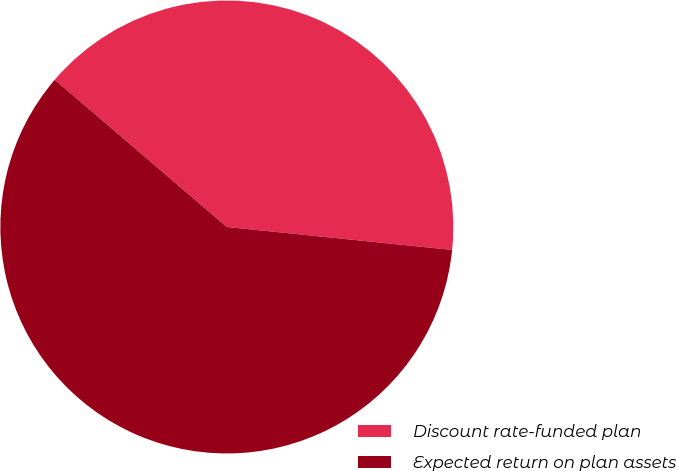<chart> <loc_0><loc_0><loc_500><loc_500><pie_chart><fcel>Discount rate-funded plan<fcel>Expected return on plan assets<nl><fcel>40.35%<fcel>59.65%<nl></chart> 